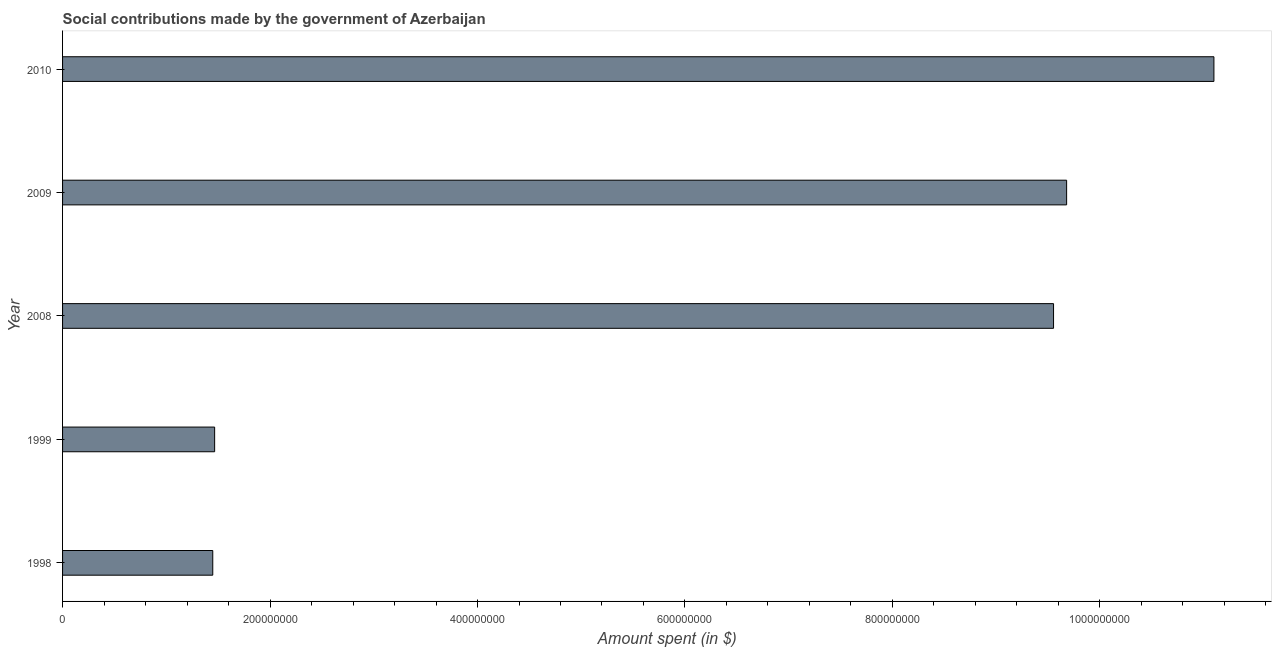Does the graph contain grids?
Ensure brevity in your answer.  No. What is the title of the graph?
Give a very brief answer. Social contributions made by the government of Azerbaijan. What is the label or title of the X-axis?
Your response must be concise. Amount spent (in $). What is the amount spent in making social contributions in 2009?
Offer a terse response. 9.68e+08. Across all years, what is the maximum amount spent in making social contributions?
Your answer should be compact. 1.11e+09. Across all years, what is the minimum amount spent in making social contributions?
Your response must be concise. 1.45e+08. What is the sum of the amount spent in making social contributions?
Keep it short and to the point. 3.32e+09. What is the difference between the amount spent in making social contributions in 1999 and 2009?
Your response must be concise. -8.21e+08. What is the average amount spent in making social contributions per year?
Ensure brevity in your answer.  6.65e+08. What is the median amount spent in making social contributions?
Keep it short and to the point. 9.55e+08. Do a majority of the years between 1998 and 2010 (inclusive) have amount spent in making social contributions greater than 560000000 $?
Make the answer very short. Yes. What is the ratio of the amount spent in making social contributions in 1999 to that in 2008?
Give a very brief answer. 0.15. What is the difference between the highest and the second highest amount spent in making social contributions?
Your answer should be compact. 1.42e+08. Is the sum of the amount spent in making social contributions in 2008 and 2009 greater than the maximum amount spent in making social contributions across all years?
Give a very brief answer. Yes. What is the difference between the highest and the lowest amount spent in making social contributions?
Make the answer very short. 9.65e+08. Are all the bars in the graph horizontal?
Make the answer very short. Yes. What is the Amount spent (in $) in 1998?
Make the answer very short. 1.45e+08. What is the Amount spent (in $) of 1999?
Make the answer very short. 1.47e+08. What is the Amount spent (in $) in 2008?
Your answer should be compact. 9.55e+08. What is the Amount spent (in $) of 2009?
Give a very brief answer. 9.68e+08. What is the Amount spent (in $) of 2010?
Keep it short and to the point. 1.11e+09. What is the difference between the Amount spent (in $) in 1998 and 1999?
Provide a short and direct response. -1.81e+06. What is the difference between the Amount spent (in $) in 1998 and 2008?
Your response must be concise. -8.11e+08. What is the difference between the Amount spent (in $) in 1998 and 2009?
Keep it short and to the point. -8.23e+08. What is the difference between the Amount spent (in $) in 1998 and 2010?
Give a very brief answer. -9.65e+08. What is the difference between the Amount spent (in $) in 1999 and 2008?
Offer a terse response. -8.09e+08. What is the difference between the Amount spent (in $) in 1999 and 2009?
Your response must be concise. -8.21e+08. What is the difference between the Amount spent (in $) in 1999 and 2010?
Give a very brief answer. -9.63e+08. What is the difference between the Amount spent (in $) in 2008 and 2009?
Ensure brevity in your answer.  -1.26e+07. What is the difference between the Amount spent (in $) in 2008 and 2010?
Provide a succinct answer. -1.55e+08. What is the difference between the Amount spent (in $) in 2009 and 2010?
Provide a succinct answer. -1.42e+08. What is the ratio of the Amount spent (in $) in 1998 to that in 1999?
Provide a short and direct response. 0.99. What is the ratio of the Amount spent (in $) in 1998 to that in 2008?
Ensure brevity in your answer.  0.15. What is the ratio of the Amount spent (in $) in 1998 to that in 2010?
Offer a terse response. 0.13. What is the ratio of the Amount spent (in $) in 1999 to that in 2008?
Your response must be concise. 0.15. What is the ratio of the Amount spent (in $) in 1999 to that in 2009?
Your answer should be compact. 0.15. What is the ratio of the Amount spent (in $) in 1999 to that in 2010?
Provide a short and direct response. 0.13. What is the ratio of the Amount spent (in $) in 2008 to that in 2009?
Give a very brief answer. 0.99. What is the ratio of the Amount spent (in $) in 2008 to that in 2010?
Ensure brevity in your answer.  0.86. What is the ratio of the Amount spent (in $) in 2009 to that in 2010?
Your response must be concise. 0.87. 